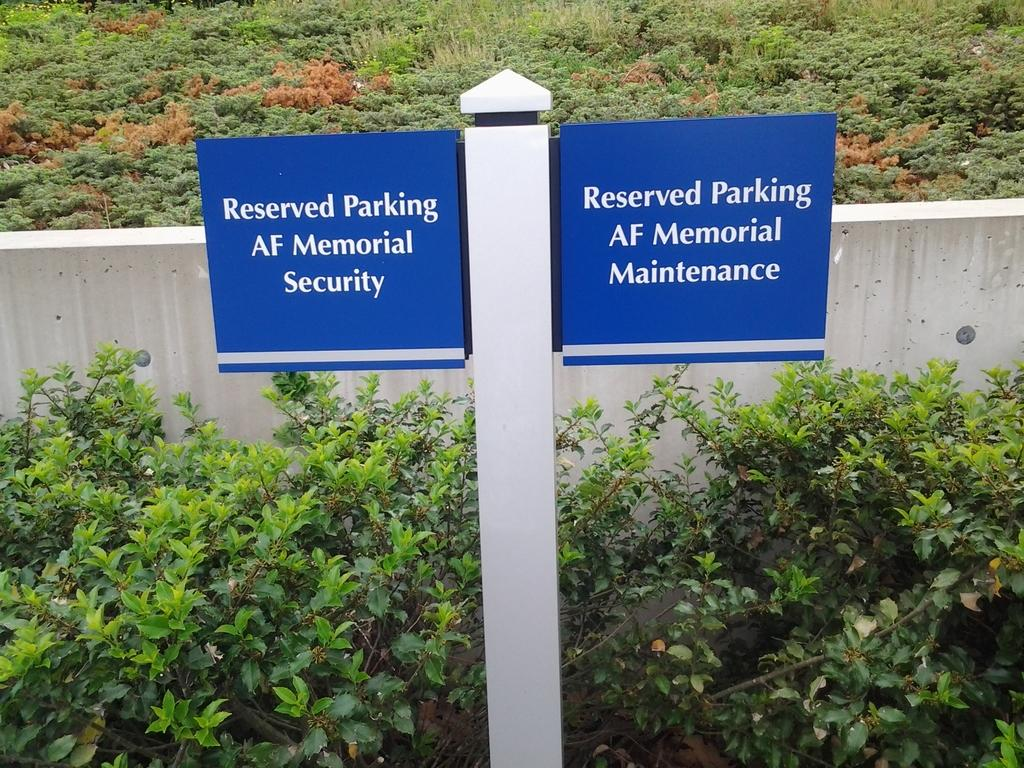What is the main structure in the image? There is a pole with two boards in the image. What type of vegetation is present in the image? There is a plant and grass in the image. What type of background can be seen in the image? There is a wall in the image. What type of steam is coming out of the plant in the image? There is no steam coming out of the plant in the image. What song is being played by the plant in the image? The plant in the image is not playing any song. How many brothers are visible in the image? There are no brothers present in the image. 